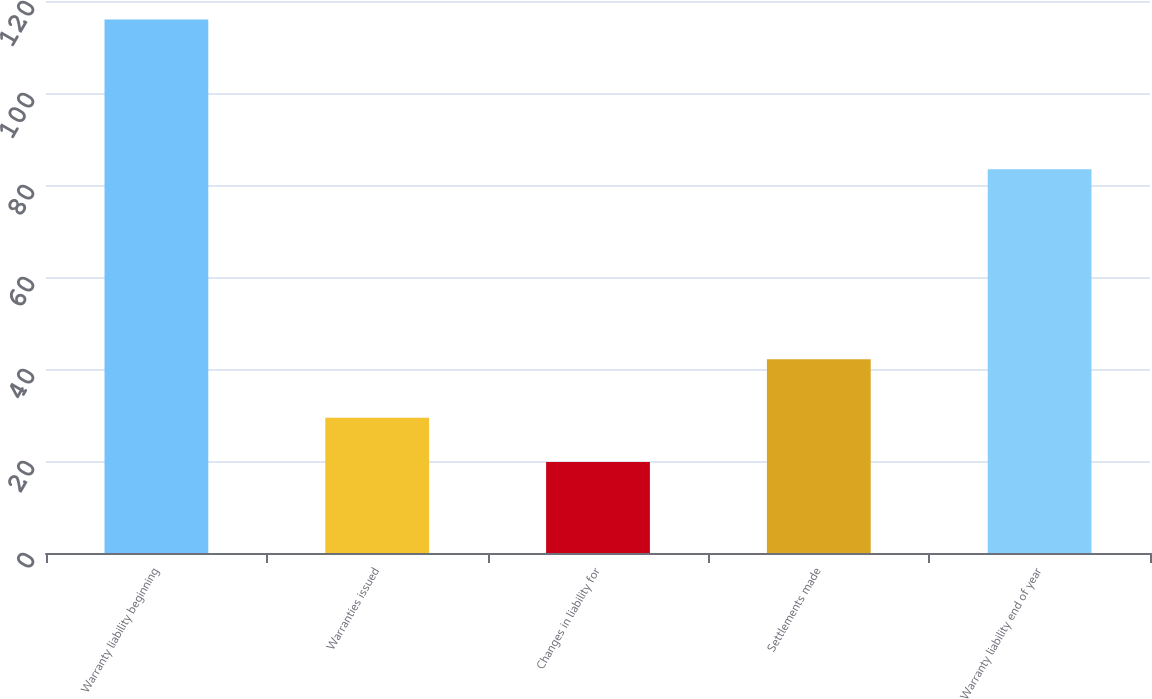<chart> <loc_0><loc_0><loc_500><loc_500><bar_chart><fcel>Warranty liability beginning<fcel>Warranties issued<fcel>Changes in liability for<fcel>Settlements made<fcel>Warranty liability end of year<nl><fcel>116<fcel>29.42<fcel>19.8<fcel>42.1<fcel>83.4<nl></chart> 